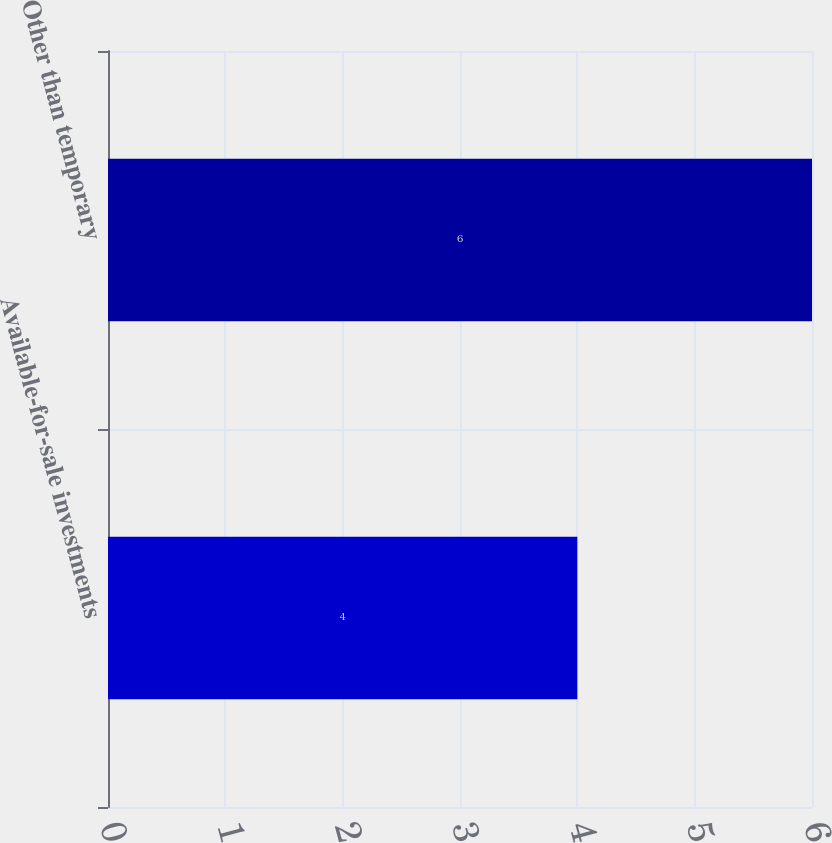<chart> <loc_0><loc_0><loc_500><loc_500><bar_chart><fcel>Available-for-sale investments<fcel>Other than temporary<nl><fcel>4<fcel>6<nl></chart> 